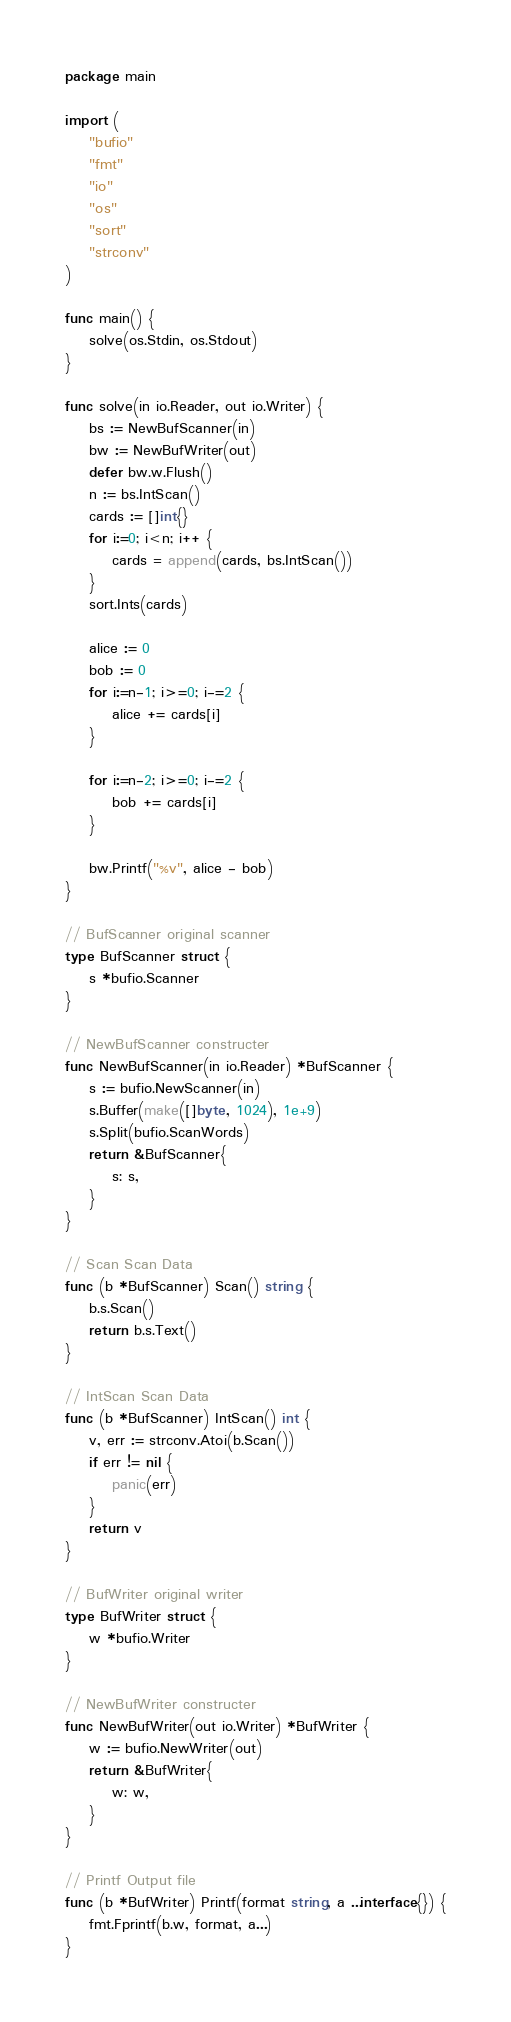<code> <loc_0><loc_0><loc_500><loc_500><_Go_>package main

import (
	"bufio"
	"fmt"
	"io"
	"os"
	"sort"
	"strconv"
)

func main() {
	solve(os.Stdin, os.Stdout)
}

func solve(in io.Reader, out io.Writer) {
	bs := NewBufScanner(in)
	bw := NewBufWriter(out)
	defer bw.w.Flush()
	n := bs.IntScan()
	cards := []int{}
	for i:=0; i<n; i++ {
		cards = append(cards, bs.IntScan())
	}
	sort.Ints(cards)

	alice := 0
	bob := 0
	for i:=n-1; i>=0; i-=2 {
		alice += cards[i]
	}

	for i:=n-2; i>=0; i-=2 {
		bob += cards[i]
	}

	bw.Printf("%v", alice - bob)
}

// BufScanner original scanner
type BufScanner struct {
	s *bufio.Scanner
}

// NewBufScanner constructer
func NewBufScanner(in io.Reader) *BufScanner {
	s := bufio.NewScanner(in)
	s.Buffer(make([]byte, 1024), 1e+9)
	s.Split(bufio.ScanWords)
	return &BufScanner{
		s: s,
	}
}

// Scan Scan Data
func (b *BufScanner) Scan() string {
	b.s.Scan()
	return b.s.Text()
}

// IntScan Scan Data
func (b *BufScanner) IntScan() int {
	v, err := strconv.Atoi(b.Scan())
	if err != nil {
		panic(err)
	}
	return v
}

// BufWriter original writer
type BufWriter struct {
	w *bufio.Writer
}

// NewBufWriter constructer
func NewBufWriter(out io.Writer) *BufWriter {
	w := bufio.NewWriter(out)
	return &BufWriter{
		w: w,
	}
}

// Printf Output file
func (b *BufWriter) Printf(format string, a ...interface{}) {
	fmt.Fprintf(b.w, format, a...)
}</code> 